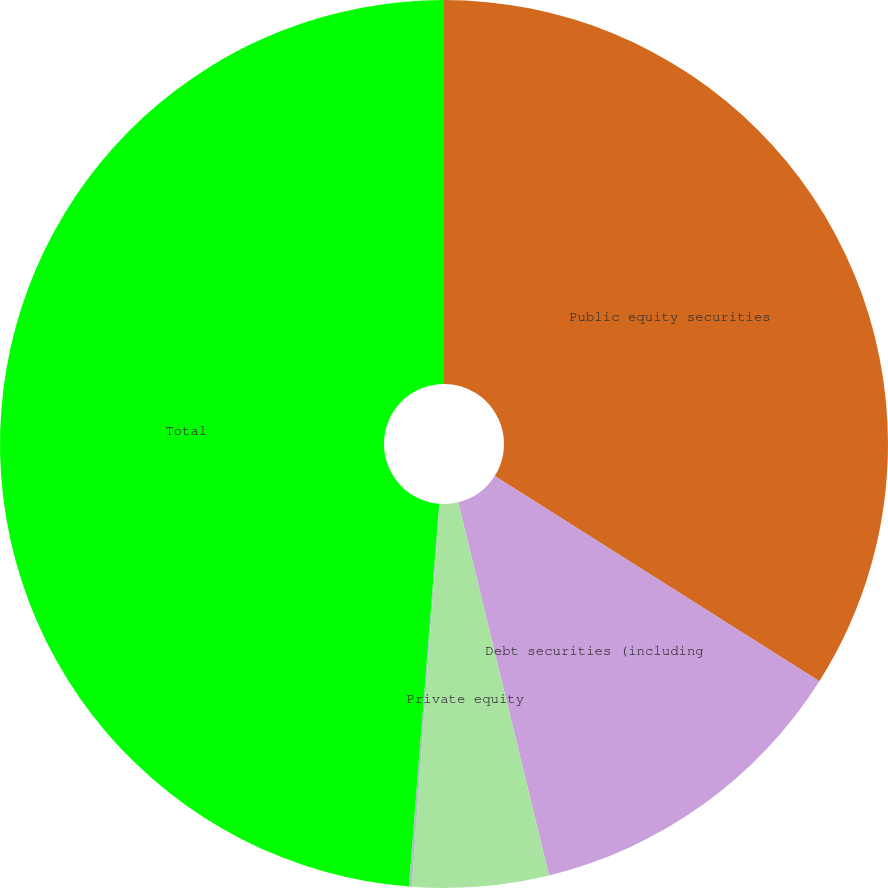<chart> <loc_0><loc_0><loc_500><loc_500><pie_chart><fcel>Public equity securities<fcel>Debt securities (including<fcel>Private equity<fcel>Other<fcel>Total<nl><fcel>33.97%<fcel>12.23%<fcel>4.96%<fcel>0.1%<fcel>48.74%<nl></chart> 